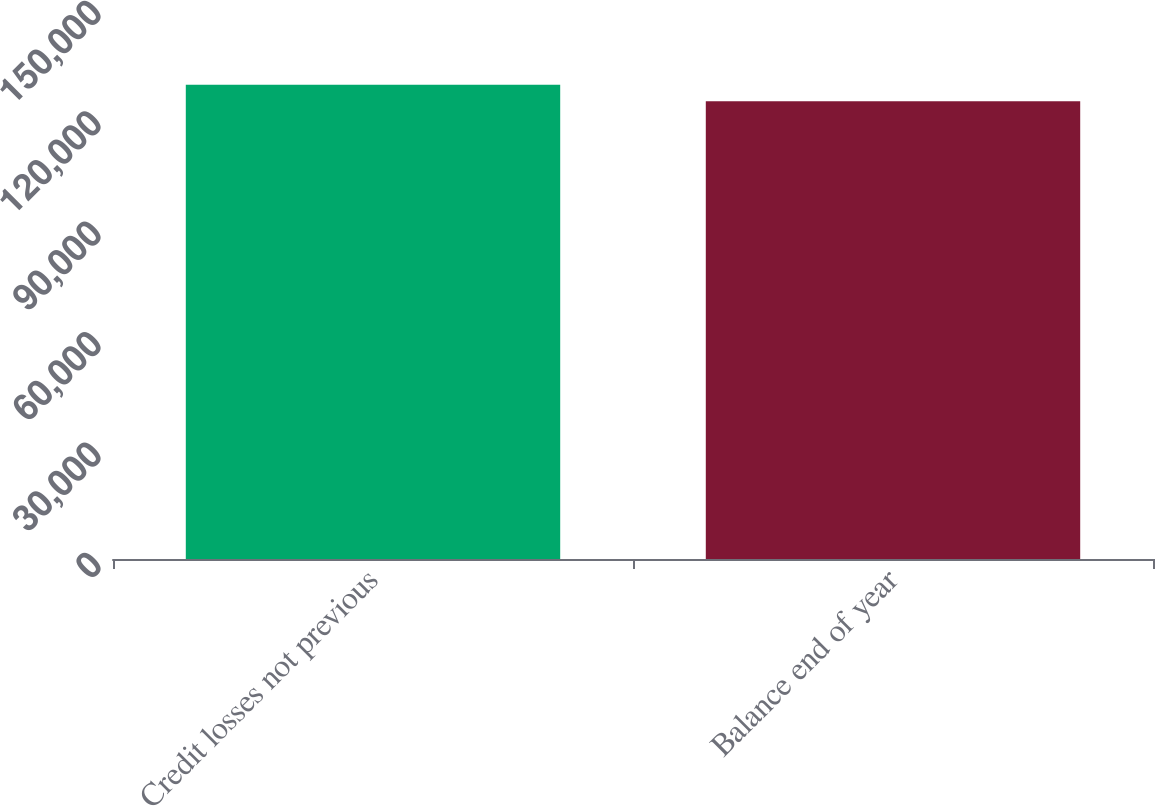Convert chart. <chart><loc_0><loc_0><loc_500><loc_500><bar_chart><fcel>Credit losses not previous<fcel>Balance end of year<nl><fcel>128892<fcel>124408<nl></chart> 